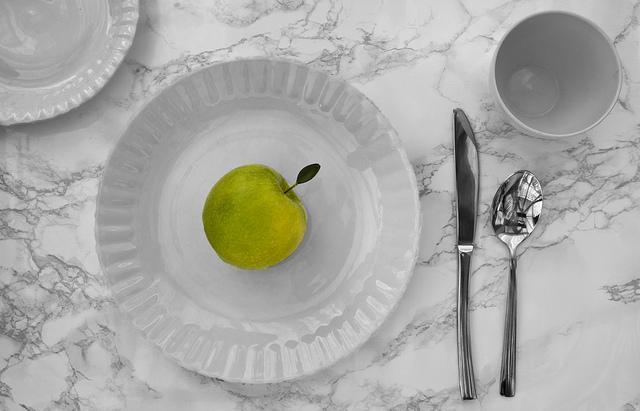How many bowls are visible?
Give a very brief answer. 2. 